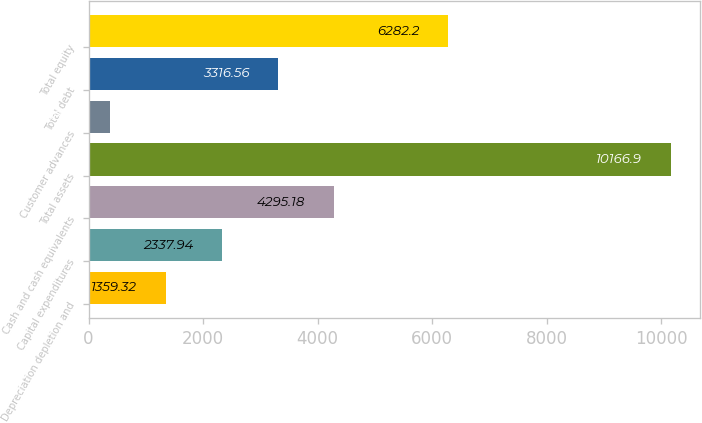<chart> <loc_0><loc_0><loc_500><loc_500><bar_chart><fcel>Depreciation depletion and<fcel>Capital expenditures<fcel>Cash and cash equivalents<fcel>Total assets<fcel>Customer advances<fcel>Total debt<fcel>Total equity<nl><fcel>1359.32<fcel>2337.94<fcel>4295.18<fcel>10166.9<fcel>380.7<fcel>3316.56<fcel>6282.2<nl></chart> 